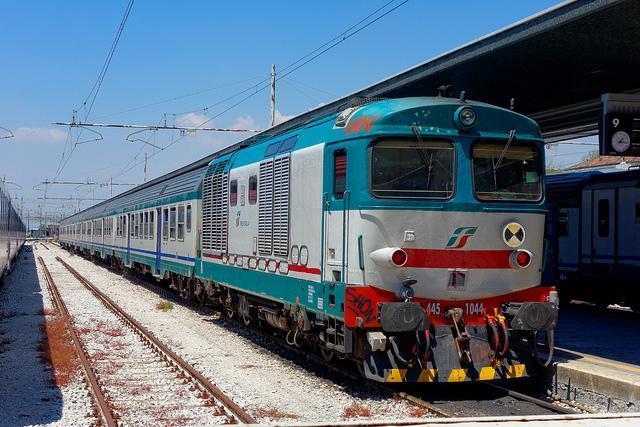How many trains are there?
Give a very brief answer. 2. 